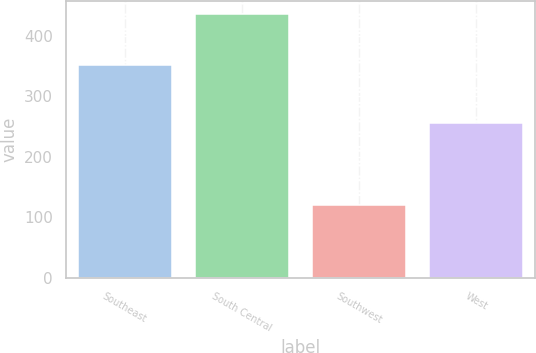<chart> <loc_0><loc_0><loc_500><loc_500><bar_chart><fcel>Southeast<fcel>South Central<fcel>Southwest<fcel>West<nl><fcel>351.6<fcel>436.4<fcel>120<fcel>256.3<nl></chart> 